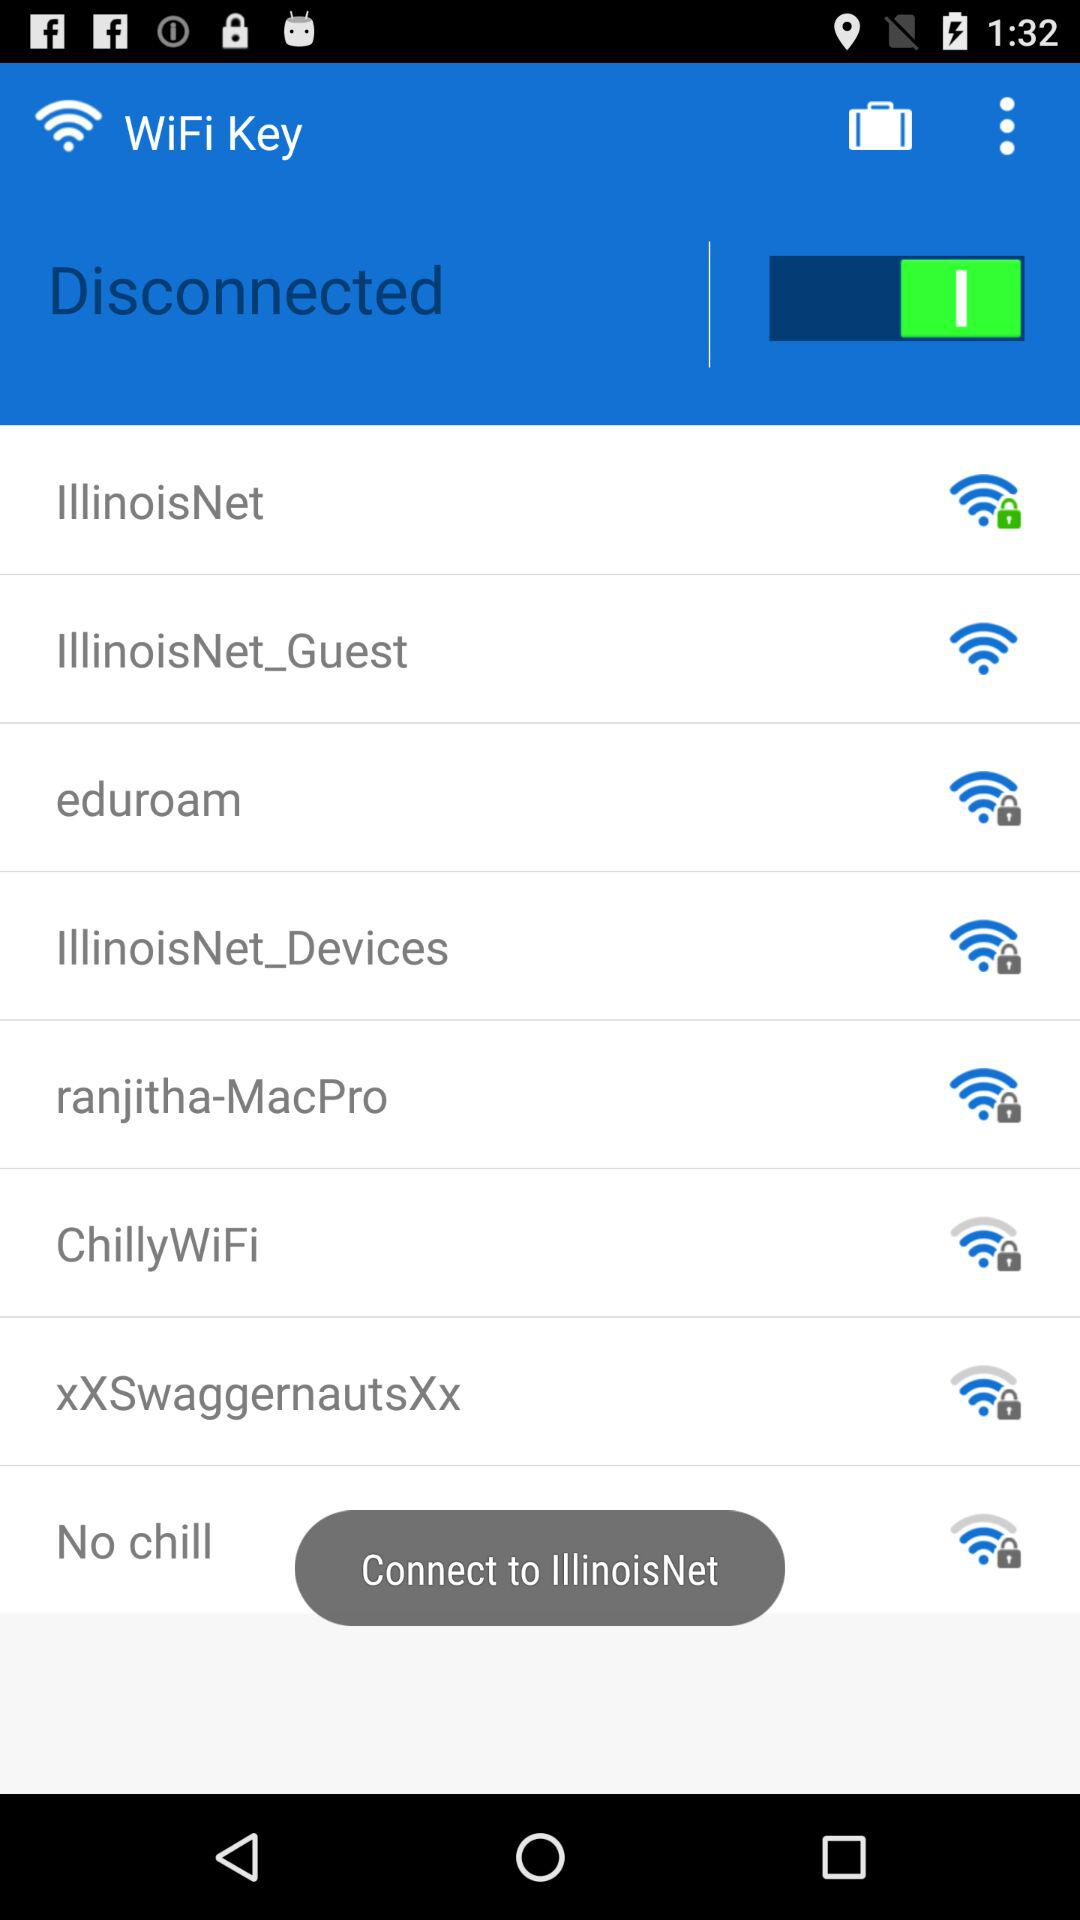What is the name of the application? The name of the application is "WiFi Key". 